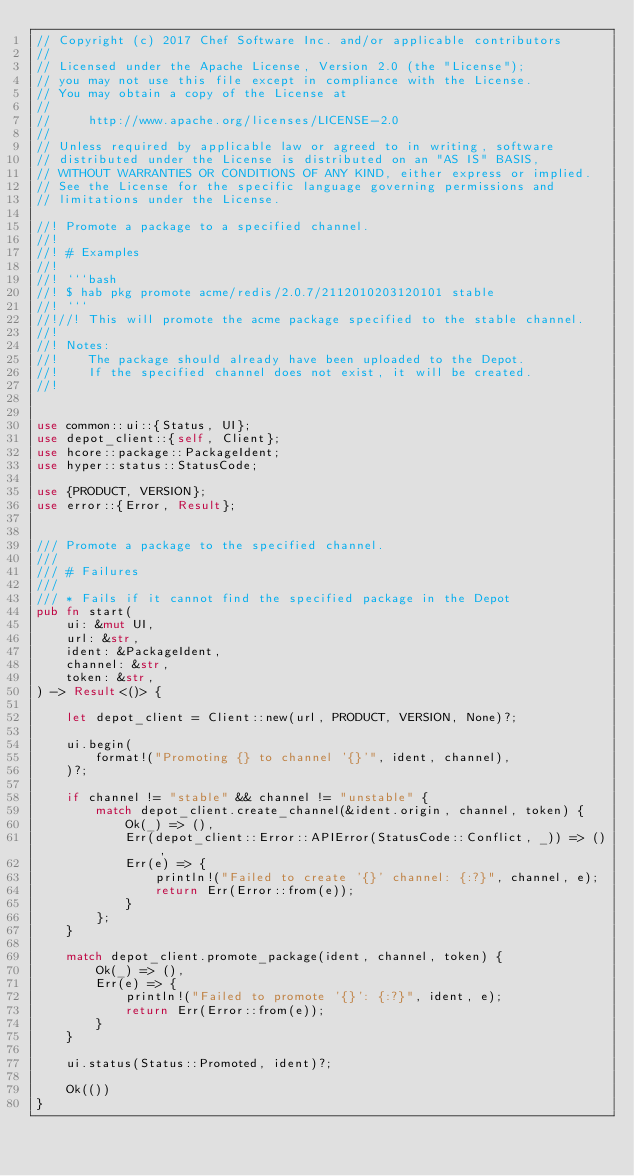Convert code to text. <code><loc_0><loc_0><loc_500><loc_500><_Rust_>// Copyright (c) 2017 Chef Software Inc. and/or applicable contributors
//
// Licensed under the Apache License, Version 2.0 (the "License");
// you may not use this file except in compliance with the License.
// You may obtain a copy of the License at
//
//     http://www.apache.org/licenses/LICENSE-2.0
//
// Unless required by applicable law or agreed to in writing, software
// distributed under the License is distributed on an "AS IS" BASIS,
// WITHOUT WARRANTIES OR CONDITIONS OF ANY KIND, either express or implied.
// See the License for the specific language governing permissions and
// limitations under the License.

//! Promote a package to a specified channel.
//!
//! # Examples
//!
//! ```bash
//! $ hab pkg promote acme/redis/2.0.7/2112010203120101 stable
//! ```
//!//! This will promote the acme package specified to the stable channel.
//!
//! Notes:
//!    The package should already have been uploaded to the Depot.
//!    If the specified channel does not exist, it will be created.
//!


use common::ui::{Status, UI};
use depot_client::{self, Client};
use hcore::package::PackageIdent;
use hyper::status::StatusCode;

use {PRODUCT, VERSION};
use error::{Error, Result};


/// Promote a package to the specified channel.
///
/// # Failures
///
/// * Fails if it cannot find the specified package in the Depot
pub fn start(
    ui: &mut UI,
    url: &str,
    ident: &PackageIdent,
    channel: &str,
    token: &str,
) -> Result<()> {

    let depot_client = Client::new(url, PRODUCT, VERSION, None)?;

    ui.begin(
        format!("Promoting {} to channel '{}'", ident, channel),
    )?;

    if channel != "stable" && channel != "unstable" {
        match depot_client.create_channel(&ident.origin, channel, token) {
            Ok(_) => (),
            Err(depot_client::Error::APIError(StatusCode::Conflict, _)) => (),
            Err(e) => {
                println!("Failed to create '{}' channel: {:?}", channel, e);
                return Err(Error::from(e));
            }
        };
    }

    match depot_client.promote_package(ident, channel, token) {
        Ok(_) => (),
        Err(e) => {
            println!("Failed to promote '{}': {:?}", ident, e);
            return Err(Error::from(e));
        }
    }

    ui.status(Status::Promoted, ident)?;

    Ok(())
}
</code> 